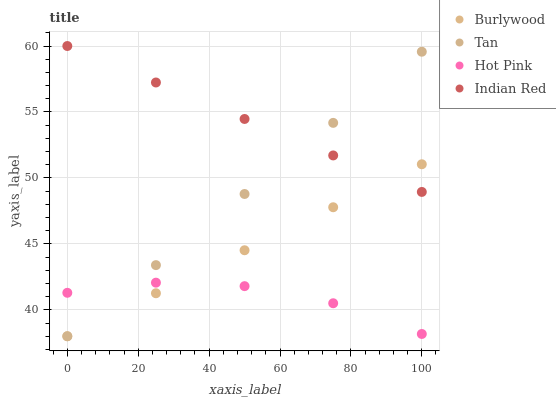Does Hot Pink have the minimum area under the curve?
Answer yes or no. Yes. Does Indian Red have the maximum area under the curve?
Answer yes or no. Yes. Does Tan have the minimum area under the curve?
Answer yes or no. No. Does Tan have the maximum area under the curve?
Answer yes or no. No. Is Tan the smoothest?
Answer yes or no. Yes. Is Hot Pink the roughest?
Answer yes or no. Yes. Is Hot Pink the smoothest?
Answer yes or no. No. Is Tan the roughest?
Answer yes or no. No. Does Burlywood have the lowest value?
Answer yes or no. Yes. Does Hot Pink have the lowest value?
Answer yes or no. No. Does Indian Red have the highest value?
Answer yes or no. Yes. Does Tan have the highest value?
Answer yes or no. No. Is Hot Pink less than Indian Red?
Answer yes or no. Yes. Is Indian Red greater than Hot Pink?
Answer yes or no. Yes. Does Burlywood intersect Hot Pink?
Answer yes or no. Yes. Is Burlywood less than Hot Pink?
Answer yes or no. No. Is Burlywood greater than Hot Pink?
Answer yes or no. No. Does Hot Pink intersect Indian Red?
Answer yes or no. No. 